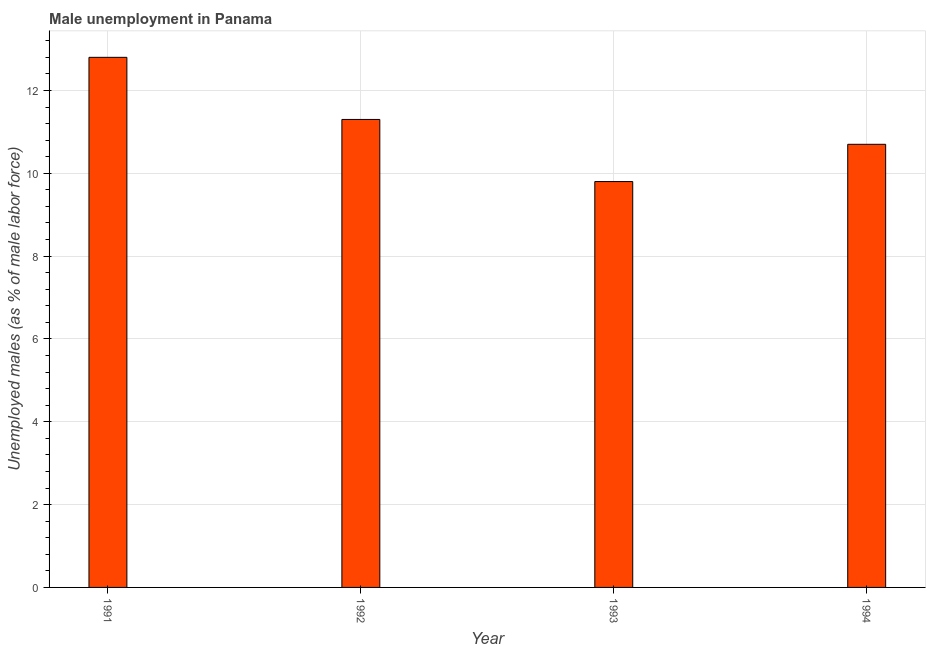What is the title of the graph?
Keep it short and to the point. Male unemployment in Panama. What is the label or title of the Y-axis?
Your answer should be very brief. Unemployed males (as % of male labor force). What is the unemployed males population in 1994?
Ensure brevity in your answer.  10.7. Across all years, what is the maximum unemployed males population?
Your response must be concise. 12.8. Across all years, what is the minimum unemployed males population?
Offer a terse response. 9.8. In which year was the unemployed males population minimum?
Provide a short and direct response. 1993. What is the sum of the unemployed males population?
Provide a succinct answer. 44.6. What is the average unemployed males population per year?
Ensure brevity in your answer.  11.15. What is the median unemployed males population?
Offer a terse response. 11. In how many years, is the unemployed males population greater than 12.4 %?
Ensure brevity in your answer.  1. Do a majority of the years between 1991 and 1992 (inclusive) have unemployed males population greater than 2 %?
Provide a succinct answer. Yes. What is the ratio of the unemployed males population in 1993 to that in 1994?
Your answer should be compact. 0.92. Is the unemployed males population in 1991 less than that in 1993?
Make the answer very short. No. Is the difference between the unemployed males population in 1991 and 1992 greater than the difference between any two years?
Offer a very short reply. No. What is the difference between the highest and the second highest unemployed males population?
Offer a terse response. 1.5. Are all the bars in the graph horizontal?
Offer a terse response. No. How many years are there in the graph?
Your response must be concise. 4. What is the difference between two consecutive major ticks on the Y-axis?
Your answer should be compact. 2. What is the Unemployed males (as % of male labor force) in 1991?
Your answer should be very brief. 12.8. What is the Unemployed males (as % of male labor force) in 1992?
Offer a very short reply. 11.3. What is the Unemployed males (as % of male labor force) of 1993?
Keep it short and to the point. 9.8. What is the Unemployed males (as % of male labor force) of 1994?
Provide a short and direct response. 10.7. What is the difference between the Unemployed males (as % of male labor force) in 1992 and 1993?
Your answer should be compact. 1.5. What is the difference between the Unemployed males (as % of male labor force) in 1993 and 1994?
Keep it short and to the point. -0.9. What is the ratio of the Unemployed males (as % of male labor force) in 1991 to that in 1992?
Provide a short and direct response. 1.13. What is the ratio of the Unemployed males (as % of male labor force) in 1991 to that in 1993?
Offer a very short reply. 1.31. What is the ratio of the Unemployed males (as % of male labor force) in 1991 to that in 1994?
Your response must be concise. 1.2. What is the ratio of the Unemployed males (as % of male labor force) in 1992 to that in 1993?
Give a very brief answer. 1.15. What is the ratio of the Unemployed males (as % of male labor force) in 1992 to that in 1994?
Ensure brevity in your answer.  1.06. What is the ratio of the Unemployed males (as % of male labor force) in 1993 to that in 1994?
Your answer should be compact. 0.92. 